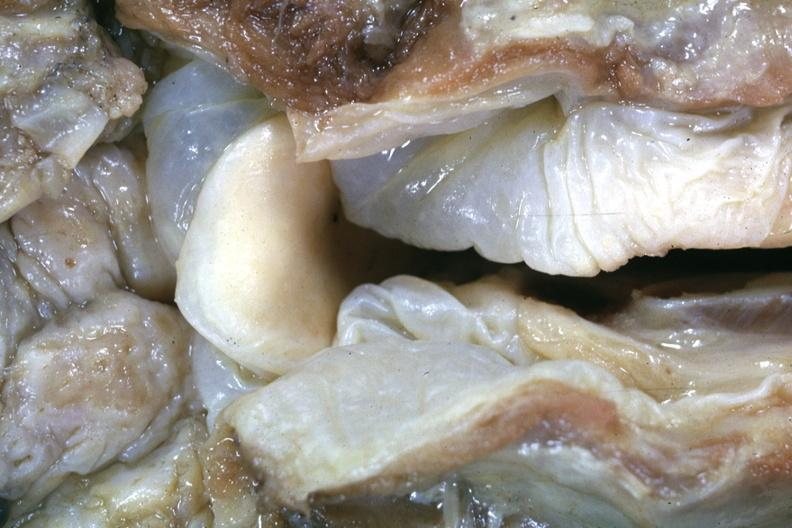what is this of a lesion seldom seen at autopsy slide?
Answer the question using a single word or phrase. A very good example 